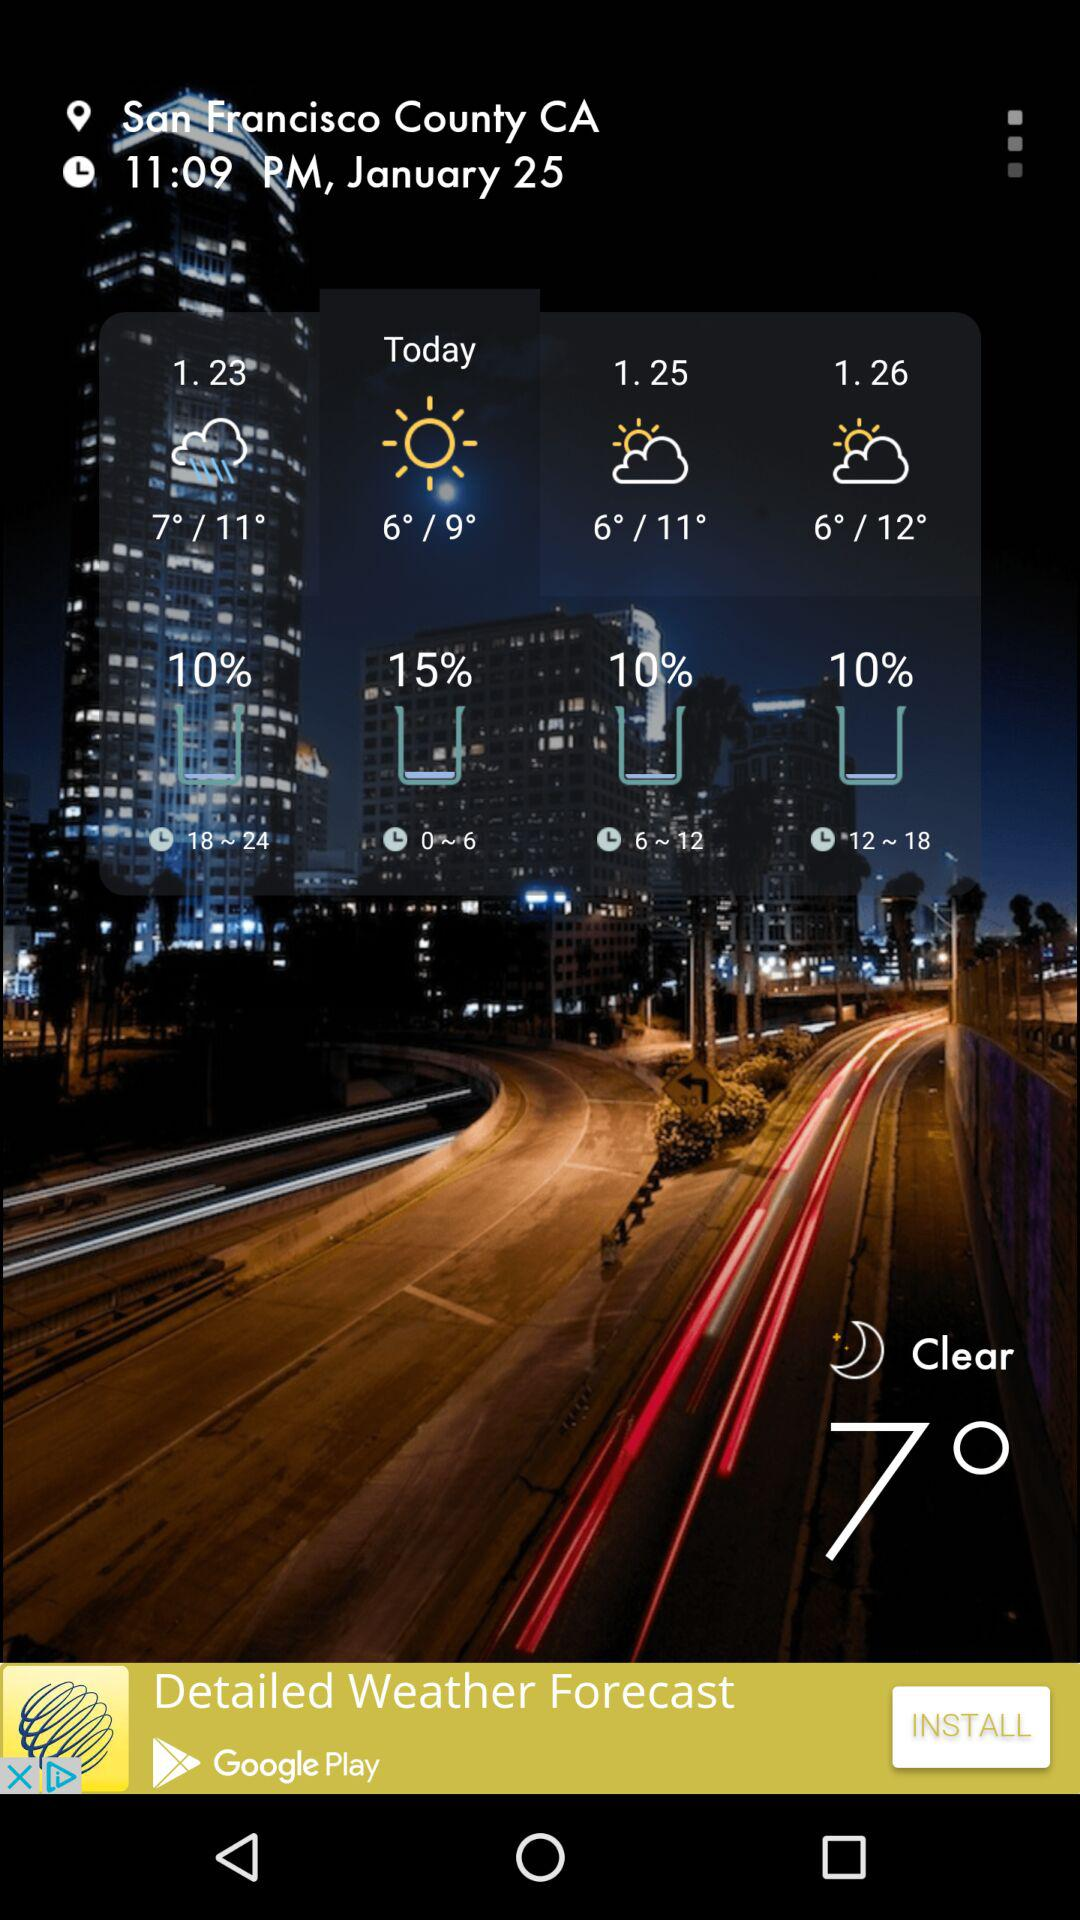What is the time? The time is 11:09 PM. 